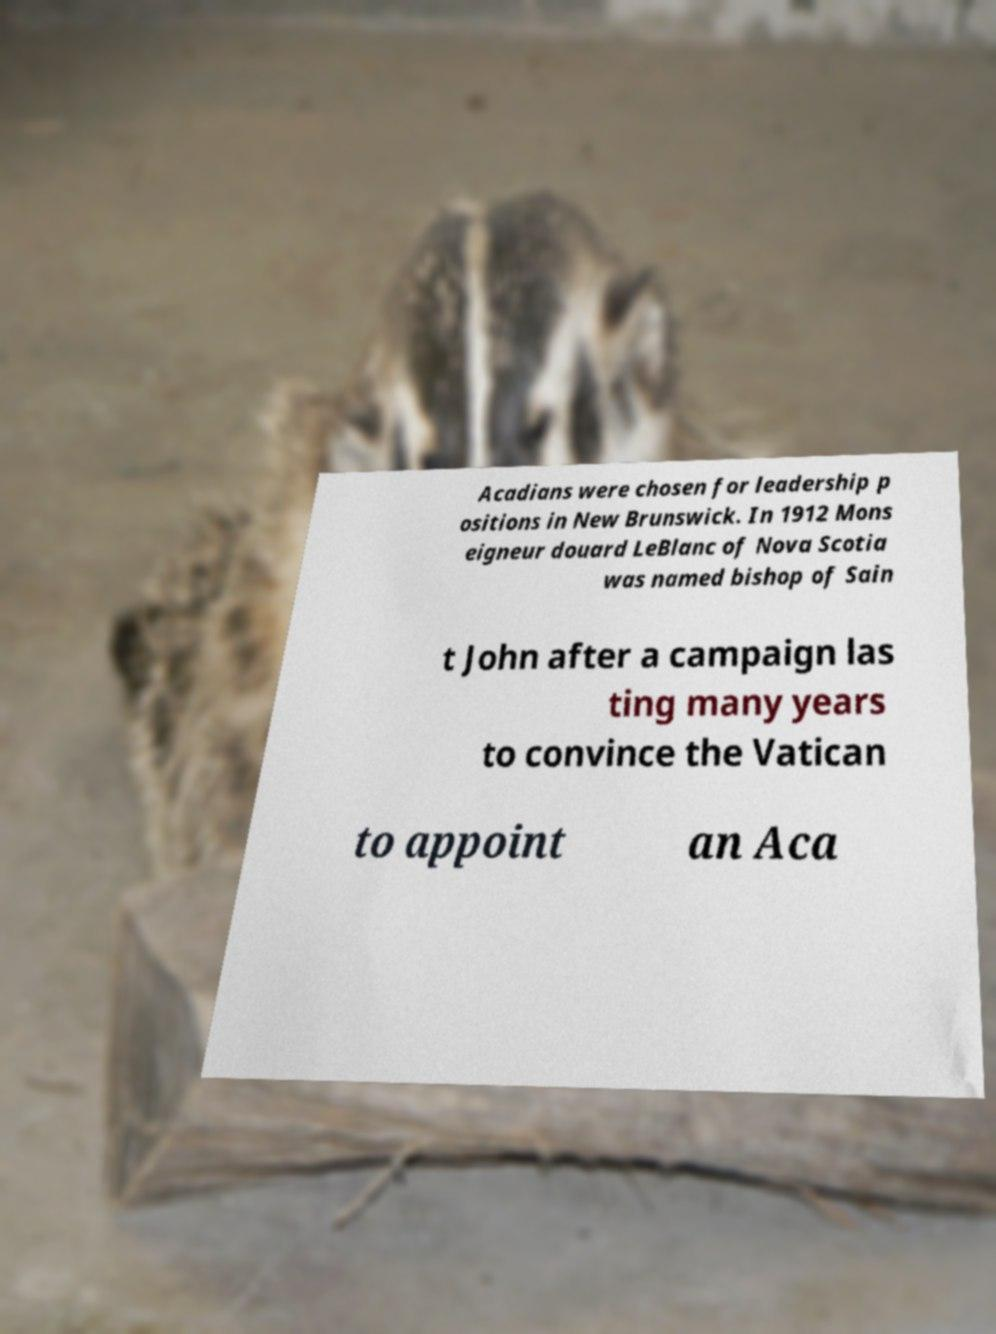I need the written content from this picture converted into text. Can you do that? Acadians were chosen for leadership p ositions in New Brunswick. In 1912 Mons eigneur douard LeBlanc of Nova Scotia was named bishop of Sain t John after a campaign las ting many years to convince the Vatican to appoint an Aca 